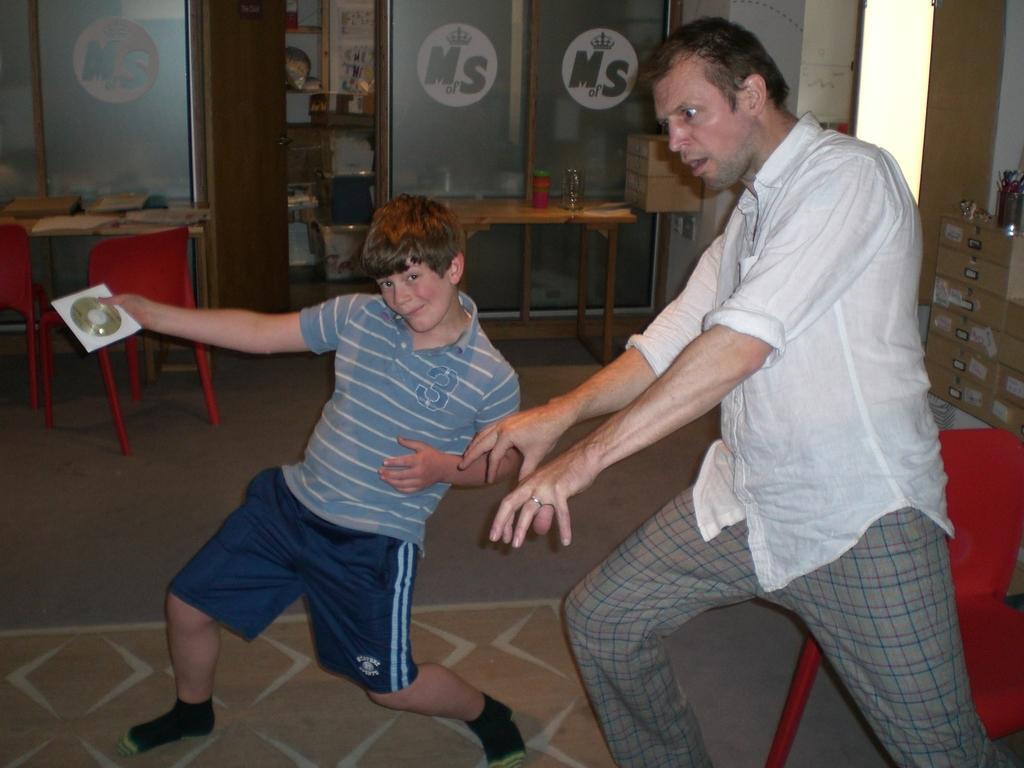Could you give a brief overview of what you see in this image? One man wearing a white shirt is standing and a boy wearing a blue dress is standing holding a CD. Behind them there is a door, table, two chairs. And another table , on the table there are some items. Some boxes are kept on the side. 